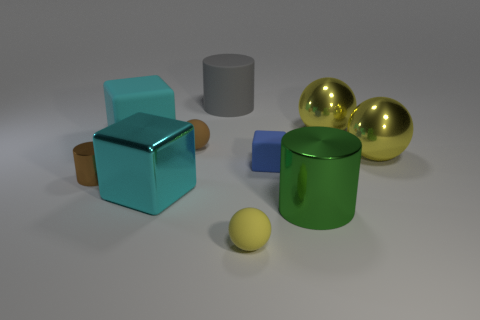The other big shiny object that is the same shape as the brown metallic thing is what color?
Offer a very short reply. Green. Is the brown rubber sphere the same size as the blue object?
Your answer should be compact. Yes. What number of things are either big purple shiny blocks or metal things that are in front of the blue matte object?
Provide a succinct answer. 3. What is the color of the tiny rubber ball that is behind the green metallic cylinder in front of the gray object?
Offer a terse response. Brown. Is the color of the rubber cube behind the brown ball the same as the big metal cube?
Provide a succinct answer. Yes. What material is the brown object in front of the small rubber block?
Keep it short and to the point. Metal. How big is the green shiny thing?
Offer a terse response. Large. Does the ball to the left of the large gray matte thing have the same material as the brown cylinder?
Your response must be concise. No. How many cubes are there?
Keep it short and to the point. 3. How many objects are small gray cubes or big cyan metallic blocks?
Keep it short and to the point. 1. 